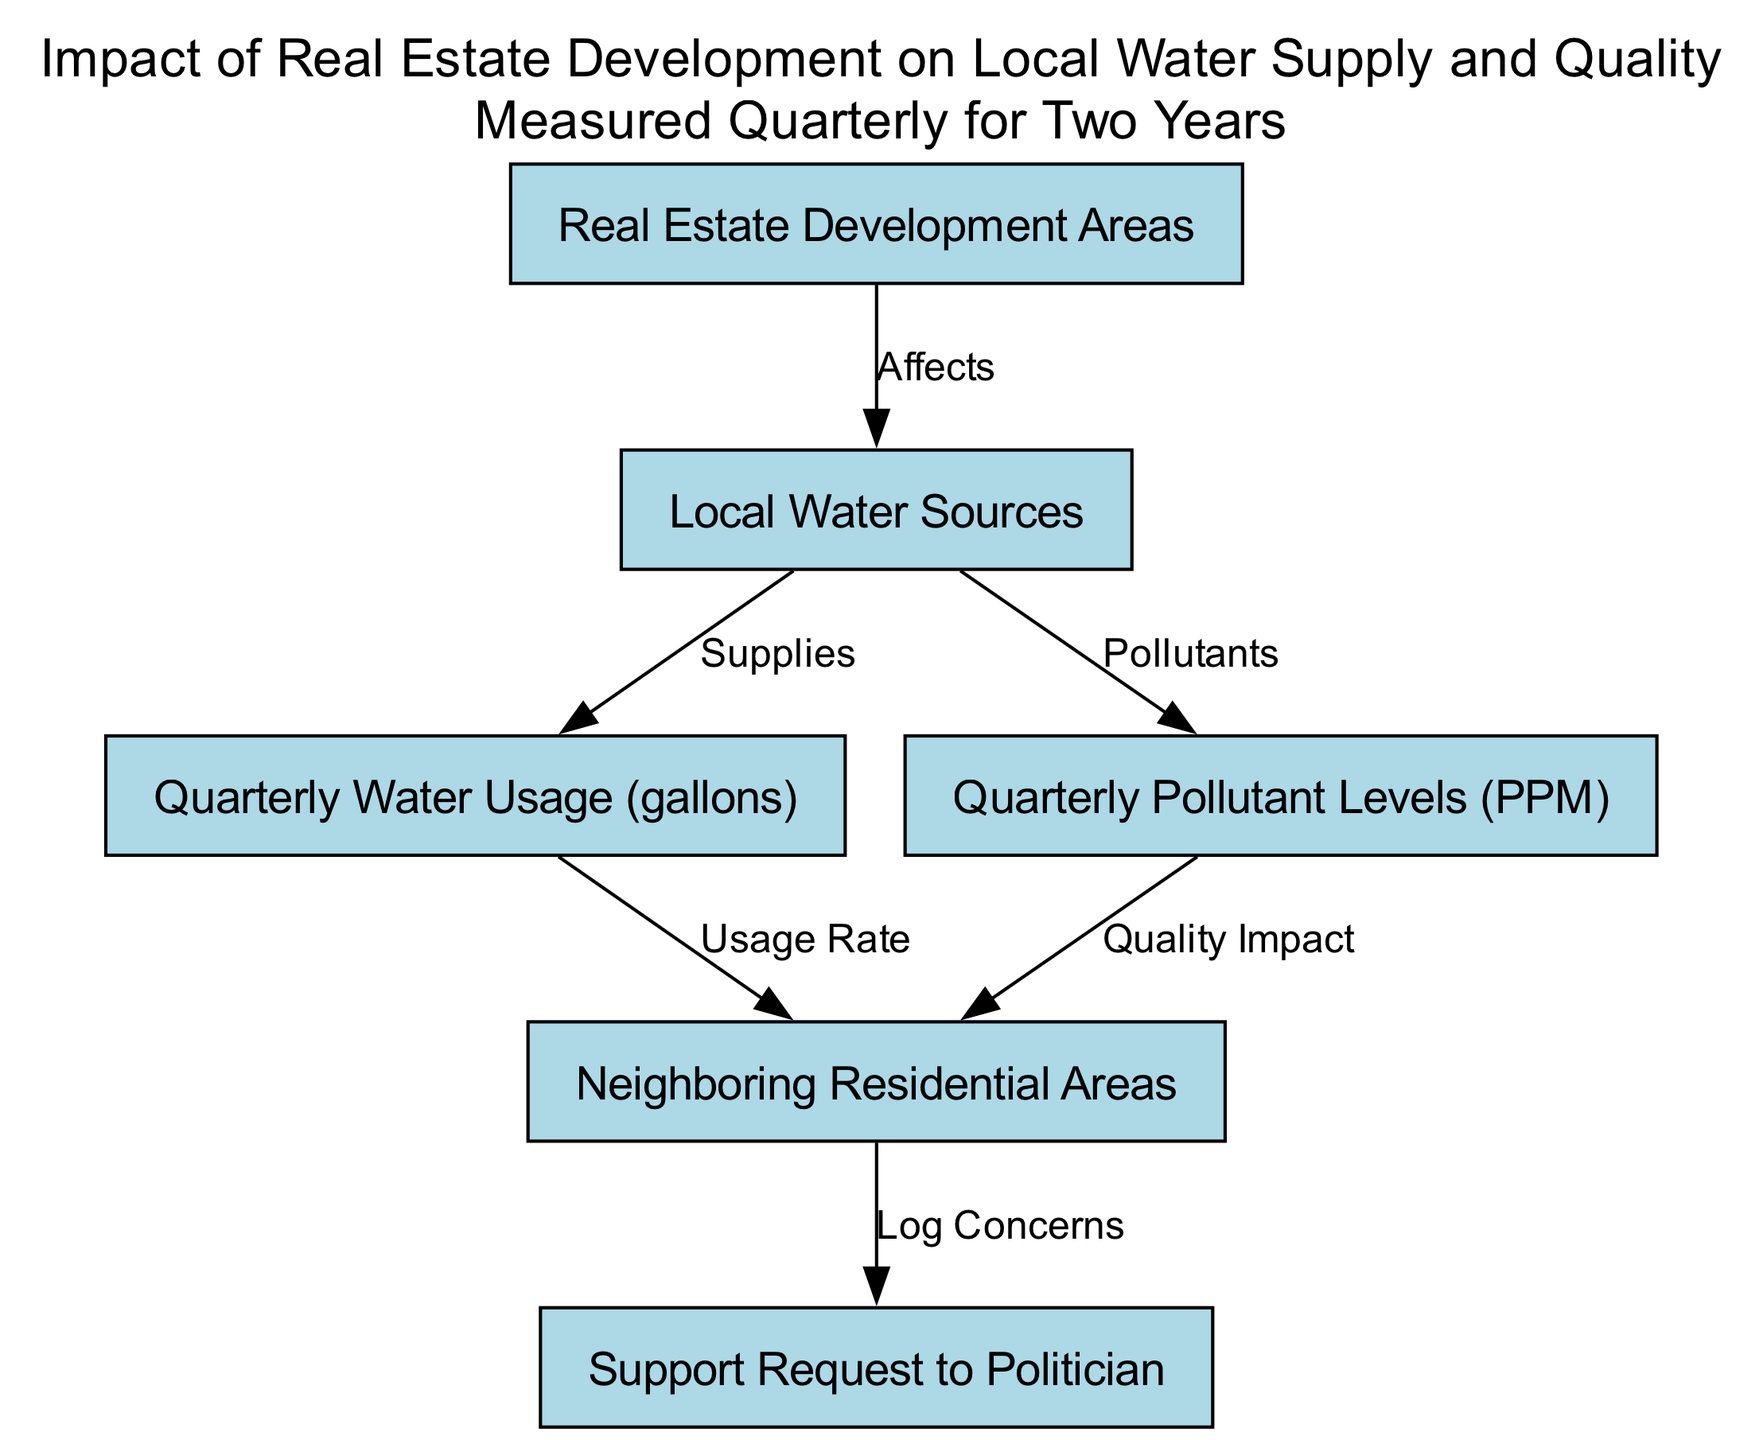What are the key areas affected by development? The nodes listed under "Real Estate Development Areas" indicate the areas that are directly impacted by real estate projects. This is the primary node regarding the influence of development.
Answer: Real Estate Development Areas How many nodes are in the diagram? The diagram contains a total of six nodes, which represent various elements related to water supply and quality impacted by real estate development.
Answer: Six What relationship exists between local water sources and pollutant levels? The edge between "Local Water Sources" and "Pollutant Levels" indicates that local water sources contribute to the pollutant levels present in the water supply, illustrating an adverse effect relationship.
Answer: Pollutants What do residential areas do in response to concerns? According to the edge from "Residential Areas" to "Support Request to Politician," residential areas log their concerns and seek support regarding the impacts of development on water supply and quality.
Answer: Log Concerns How does water usage affect neighboring residential areas? The diagram shows an edge from "Quarterly Water Usage" to "Neighboring Residential Areas," meaning that the volume of water used impacts the neighboring residential areas, likely in terms of availability.
Answer: Usage Rate What is the main outcome affecting residential areas? The edges from both "Pollutant Levels" and "Water Usage" lead to "Neighboring Residential Areas," indicating that the water quality and usage both significantly impact these residential areas.
Answer: Quality Impact How many edges connect the nodes in the diagram? By counting the edges represented, there are a total of five edges that connect the nodes, illustrating various relationships between the elements involved.
Answer: Five What do water sources provide to residential areas based on the diagram? "Local Water Sources" is connected by an edge to "Quarterly Water Usage," which shows that the water sources supply the water used in the neighboring residential areas.
Answer: Supplies Which node is the final destination for concerns logged by residential areas? The "Support Request to Politician" is the endpoint for concerns from the "Residential Areas," indicating where they direct their requests for intervention regarding the impacts they face.
Answer: Support Request to Politician 